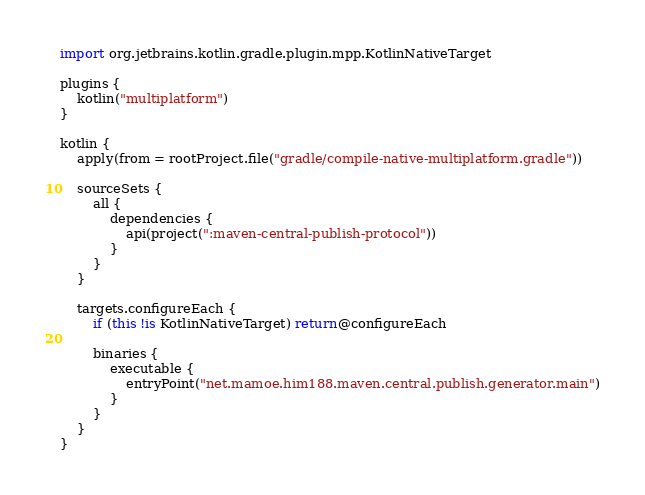Convert code to text. <code><loc_0><loc_0><loc_500><loc_500><_Kotlin_>import org.jetbrains.kotlin.gradle.plugin.mpp.KotlinNativeTarget

plugins {
    kotlin("multiplatform")
}

kotlin {
    apply(from = rootProject.file("gradle/compile-native-multiplatform.gradle"))

    sourceSets {
        all {
            dependencies {
                api(project(":maven-central-publish-protocol"))
            }
        }
    }

    targets.configureEach {
        if (this !is KotlinNativeTarget) return@configureEach

        binaries {
            executable {
                entryPoint("net.mamoe.him188.maven.central.publish.generator.main")
            }
        }
    }
}</code> 